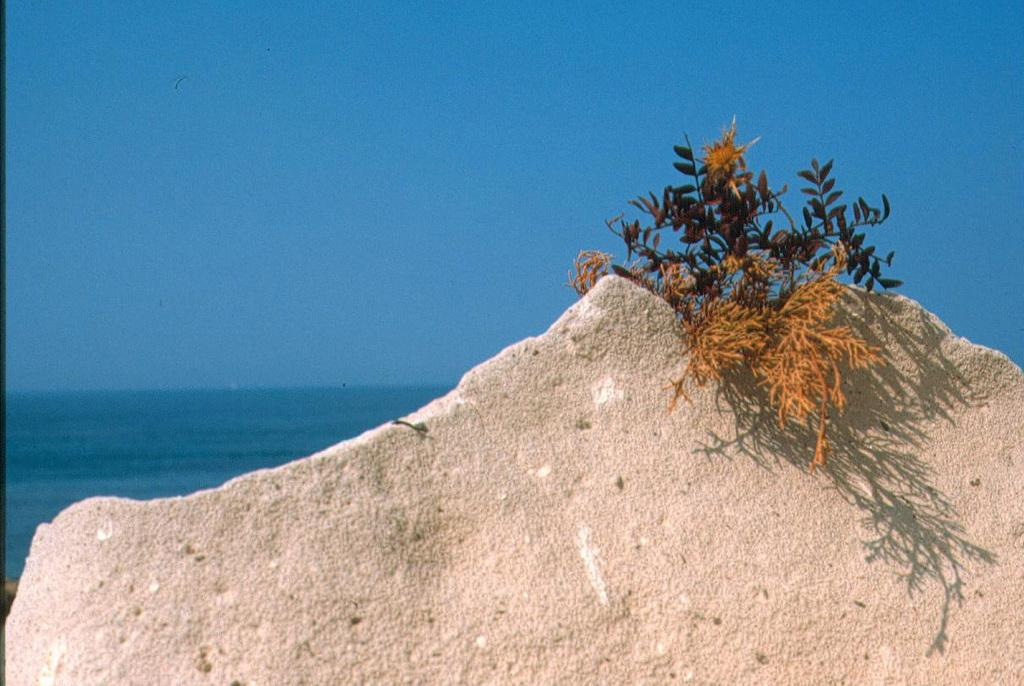What is located at the bottom of the image? There is a rock at the bottom of the image. What is growing on the rock? There are plants on the rock. What can be seen in the background of the image? There is water visible in the background of the image. What is visible in the sky? There are clouds in the sky. How many frogs are hopping on the rock in the image? There are no frogs present in the image; it features a rock with plants and a background with water and clouds. 